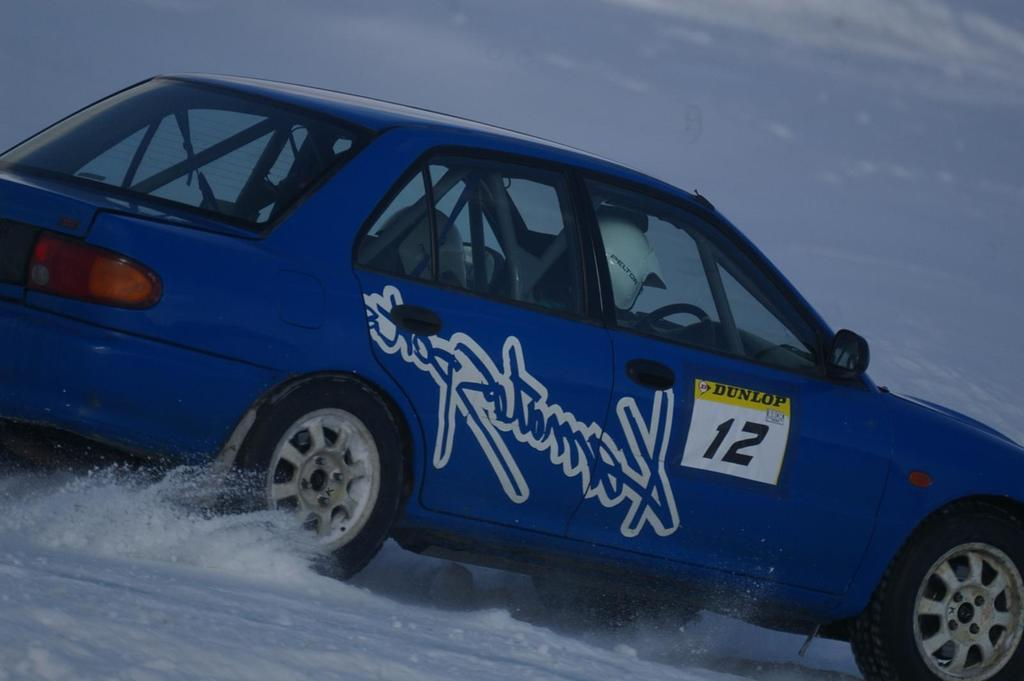What is the main element present in the image? There is water in the image. What type of vehicle can be seen in the image? There is a blue color car in the image. What part of the natural environment is visible in the image? The sky is visible in the image. What can be observed in the sky? Clouds are present in the sky. What type of paste is being used to fix the seat in the image? There is no seat or paste present in the image. 